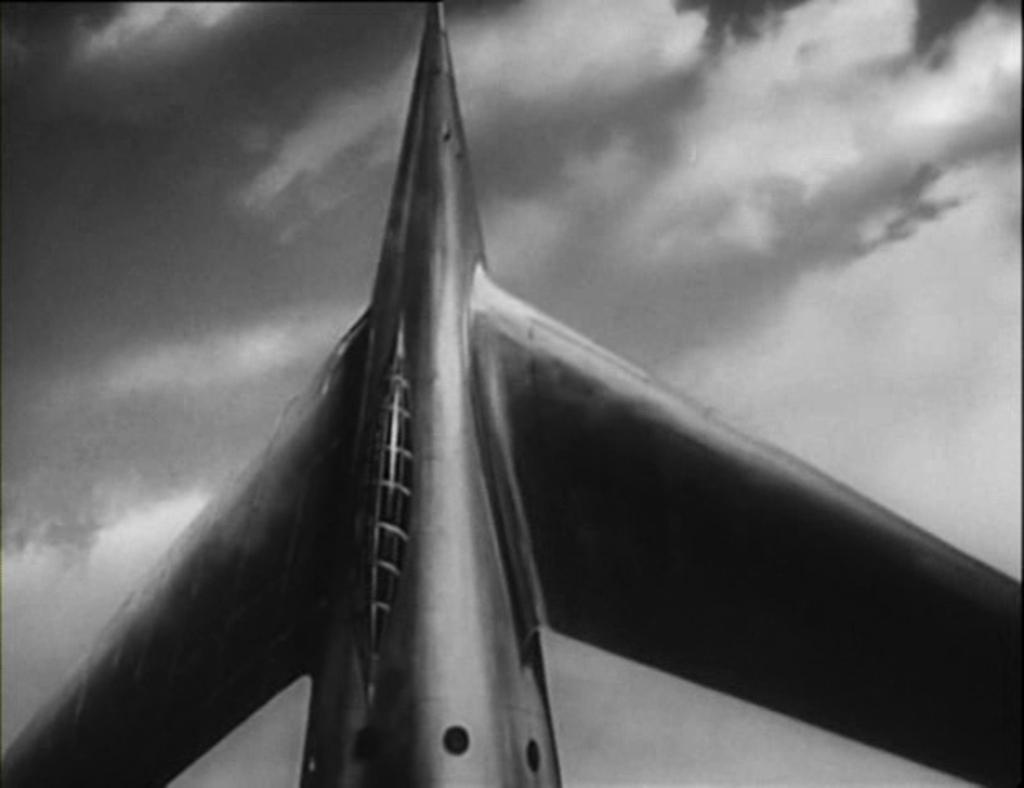Describe this image in one or two sentences. In this image, we can see a rocket. In the background, we can see some clouds. 